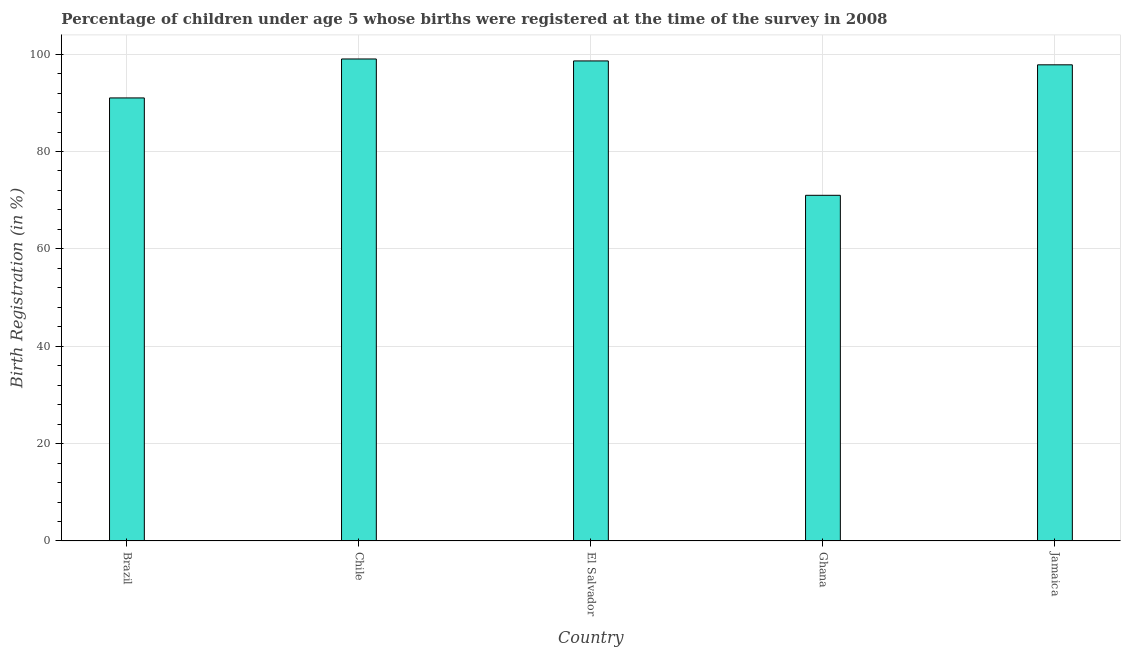Does the graph contain any zero values?
Your answer should be very brief. No. What is the title of the graph?
Ensure brevity in your answer.  Percentage of children under age 5 whose births were registered at the time of the survey in 2008. What is the label or title of the X-axis?
Offer a very short reply. Country. What is the label or title of the Y-axis?
Offer a very short reply. Birth Registration (in %). What is the birth registration in Jamaica?
Your answer should be very brief. 97.8. Across all countries, what is the maximum birth registration?
Your response must be concise. 99. Across all countries, what is the minimum birth registration?
Keep it short and to the point. 71. In which country was the birth registration maximum?
Offer a very short reply. Chile. In which country was the birth registration minimum?
Make the answer very short. Ghana. What is the sum of the birth registration?
Give a very brief answer. 457.4. What is the average birth registration per country?
Keep it short and to the point. 91.48. What is the median birth registration?
Provide a succinct answer. 97.8. What is the ratio of the birth registration in Brazil to that in Ghana?
Provide a succinct answer. 1.28. Is the birth registration in El Salvador less than that in Jamaica?
Offer a terse response. No. Is the sum of the birth registration in Chile and El Salvador greater than the maximum birth registration across all countries?
Keep it short and to the point. Yes. What is the difference between the highest and the lowest birth registration?
Offer a terse response. 28. Are all the bars in the graph horizontal?
Give a very brief answer. No. What is the difference between two consecutive major ticks on the Y-axis?
Offer a terse response. 20. Are the values on the major ticks of Y-axis written in scientific E-notation?
Provide a succinct answer. No. What is the Birth Registration (in %) of Brazil?
Offer a very short reply. 91. What is the Birth Registration (in %) of El Salvador?
Your response must be concise. 98.6. What is the Birth Registration (in %) of Jamaica?
Offer a very short reply. 97.8. What is the difference between the Birth Registration (in %) in Brazil and Chile?
Provide a succinct answer. -8. What is the difference between the Birth Registration (in %) in Brazil and Jamaica?
Provide a succinct answer. -6.8. What is the difference between the Birth Registration (in %) in Chile and El Salvador?
Ensure brevity in your answer.  0.4. What is the difference between the Birth Registration (in %) in Chile and Ghana?
Your answer should be compact. 28. What is the difference between the Birth Registration (in %) in Chile and Jamaica?
Offer a very short reply. 1.2. What is the difference between the Birth Registration (in %) in El Salvador and Ghana?
Your answer should be compact. 27.6. What is the difference between the Birth Registration (in %) in Ghana and Jamaica?
Your answer should be very brief. -26.8. What is the ratio of the Birth Registration (in %) in Brazil to that in Chile?
Offer a terse response. 0.92. What is the ratio of the Birth Registration (in %) in Brazil to that in El Salvador?
Offer a terse response. 0.92. What is the ratio of the Birth Registration (in %) in Brazil to that in Ghana?
Give a very brief answer. 1.28. What is the ratio of the Birth Registration (in %) in Brazil to that in Jamaica?
Give a very brief answer. 0.93. What is the ratio of the Birth Registration (in %) in Chile to that in Ghana?
Give a very brief answer. 1.39. What is the ratio of the Birth Registration (in %) in El Salvador to that in Ghana?
Provide a short and direct response. 1.39. What is the ratio of the Birth Registration (in %) in Ghana to that in Jamaica?
Your answer should be compact. 0.73. 